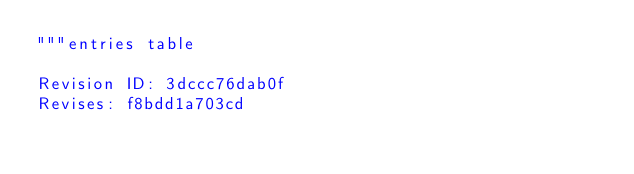<code> <loc_0><loc_0><loc_500><loc_500><_Python_>"""entries table

Revision ID: 3dccc76dab0f
Revises: f8bdd1a703cd</code> 